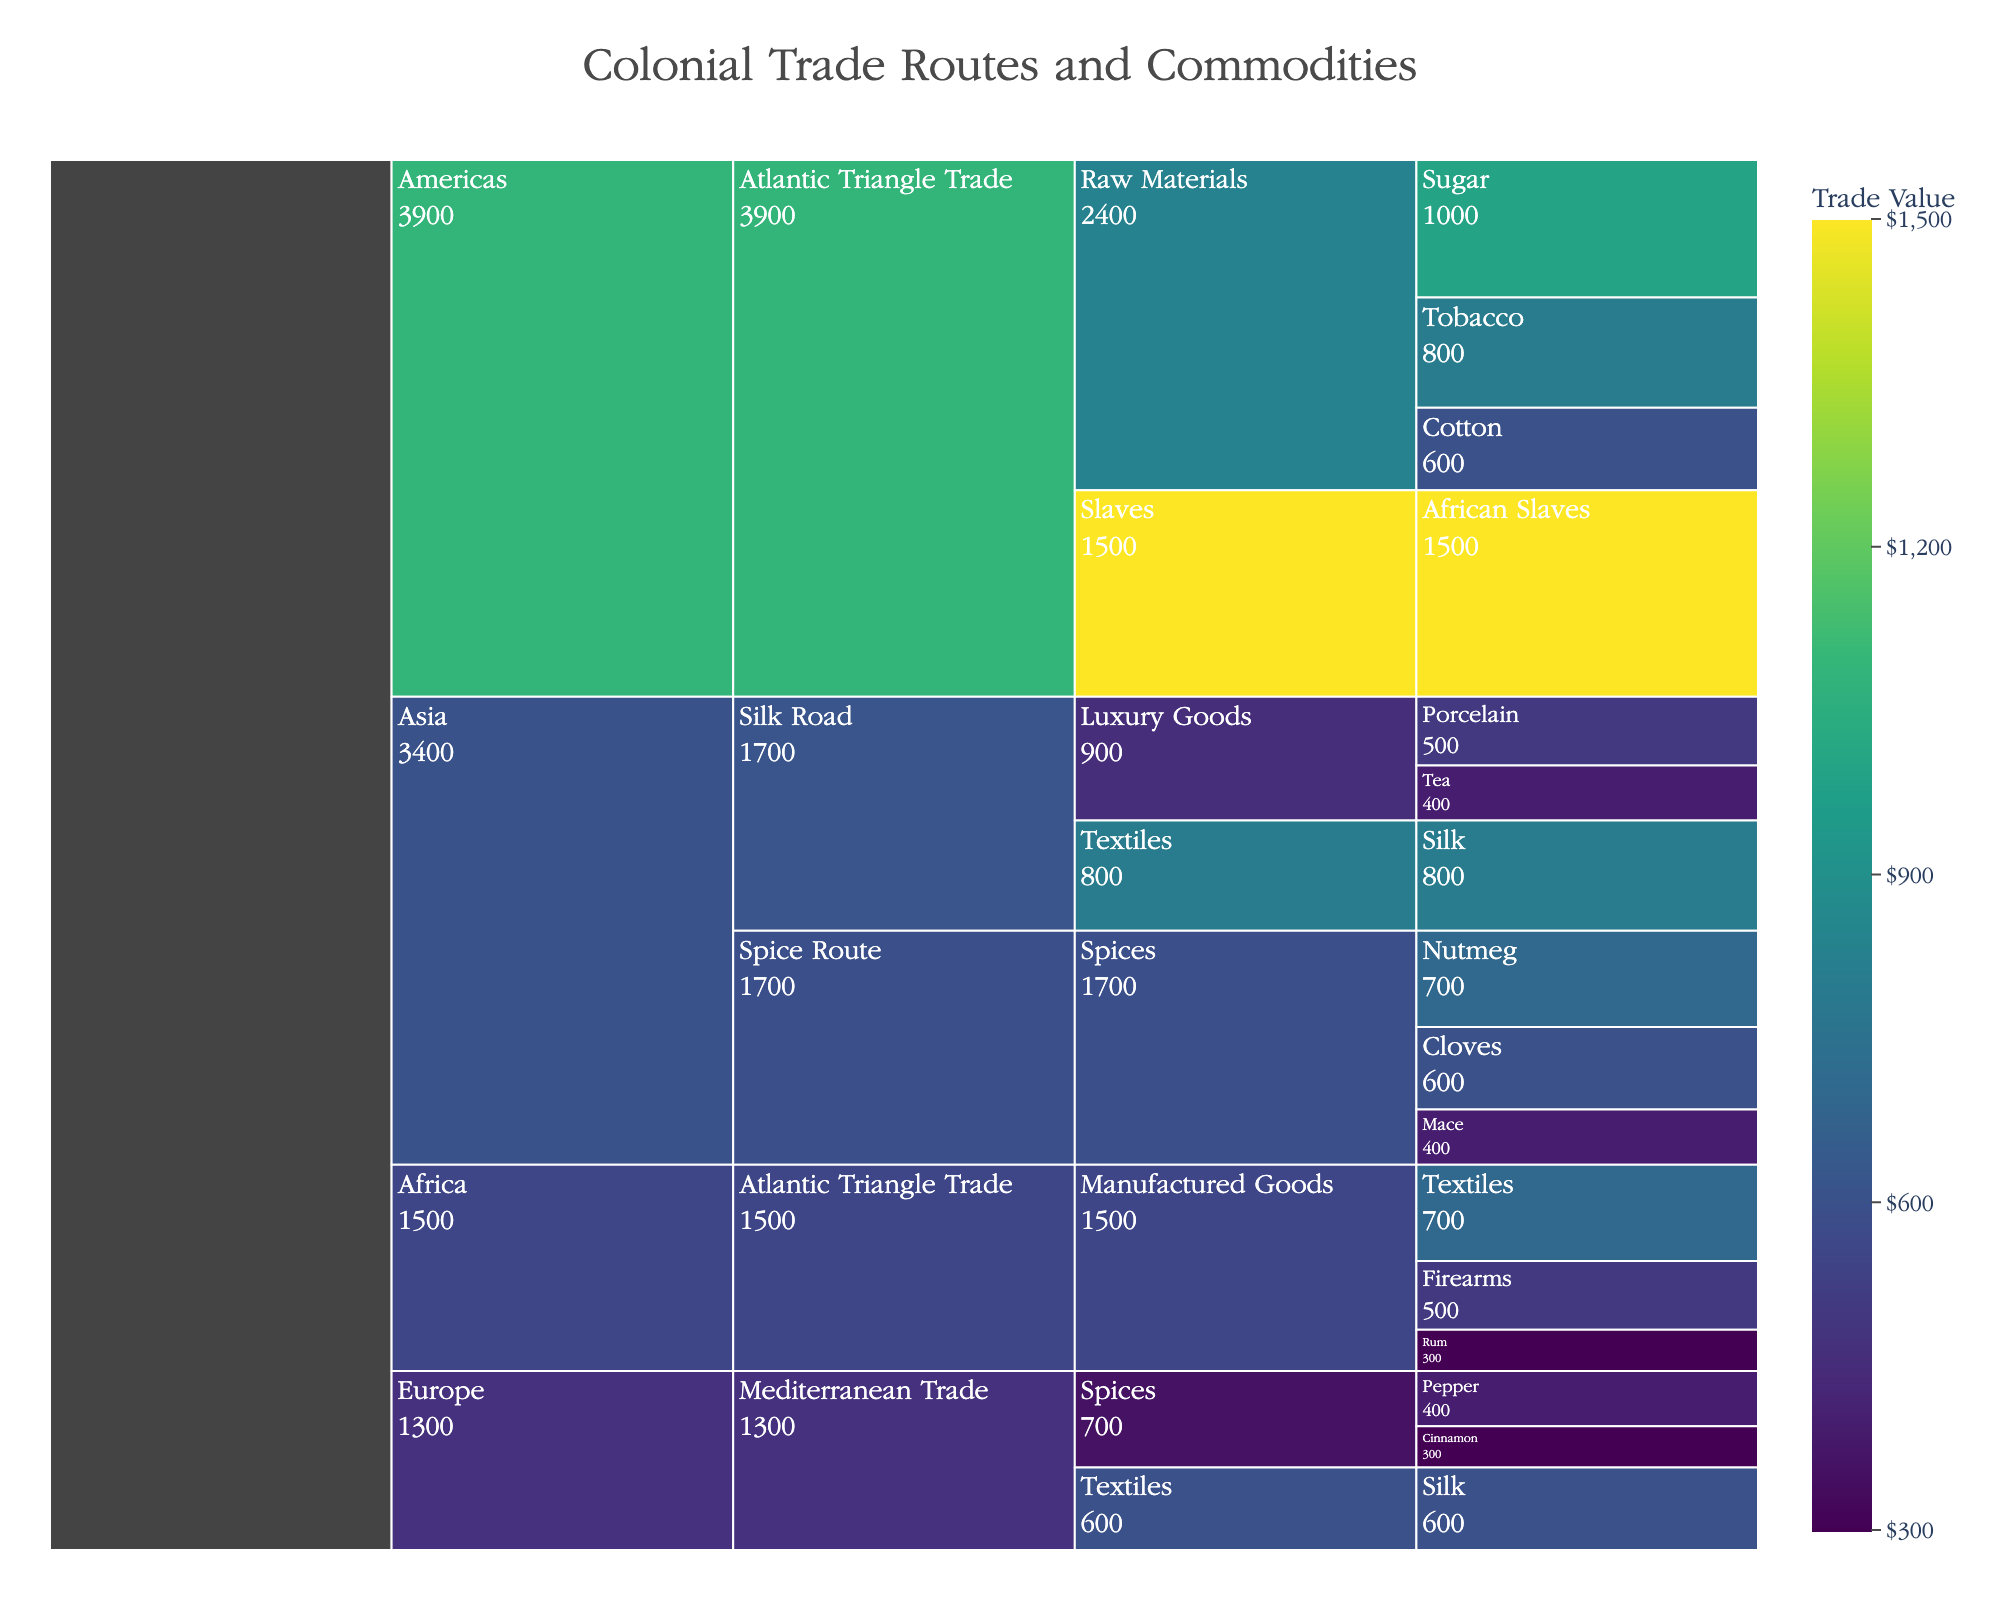What is the title of the Icicle Chart? The title is displayed at the top of the figure and generalizes the content shown. The title of this Icicle Chart can be readily observed directly from the plot.
Answer: Colonial Trade Routes and Commodities Which region has the highest total trade value? To determine the region with the highest total trade value, look at the broadest sections in the chart that represent each region, and compare the aggregated values displayed. The Americas have a high total value due to significant segments for raw materials and slaves.
Answer: Americas What specific commodity under the Silk Road has the highest value? Focus on the part of the Icicle Chart representing Asia and trace the path down to the Silk Road section. Examine and compare the value indicators for commodities listed under it.
Answer: Silk Which commodity type in the Atlantic Triangle Trade has the smallest trade value? Navigate the sections under the Atlantic Triangle Trade and compare the aggregated values of the commodity types displayed, identifying the smallest one.
Answer: Manufactured Goods What is the total trade value of all spices exported from Asia? Sum the values of Nutmeg, Cloves, and Mace, which are listed as spices under Asia. The values are 700, 600, and 400, respectively. Calculation: 700 + 600 + 400.
Answer: 1700 Which specific commodity has a higher trade value: Tobacco or Cloves? Locate the specific sections for Tobacco under the Atlantic Triangle Trade for the Americas and Cloves under the Spice Route for Asia. Compare the values displayed for these two commodities.
Answer: Tobacco How does the trade value of Sugar compare to that of Textiles in Africa? Look at the value indicators for Sugar under the Atlantic Triangle Trade for the Americas and for Textiles under the same trade route for Africa. Compare the values shown.
Answer: Sugar is higher What are the proportions of different commodities in the Atlantic Triangle Trade for the Americas? For each specific commodity under the Atlantic Triangle Trade for the Americas (Sugar, Tobacco, Cotton, and African Slaves), compute the proportion by dividing each value by the total value for the region, then convert to percentages.
Answer: Sugar 25%, Tobacco 20%, Cotton 15%, African Slaves 37.5% Among the traded manufactured goods in African Atlantic Triangle Trade, which specific commodity has the highest value? Find the section under the Atlantic Triangle Trade for Africa dealing with manufactured goods. Compare the values for Textiles, Firearms, and Rum, identifying the highest one.
Answer: Textiles 